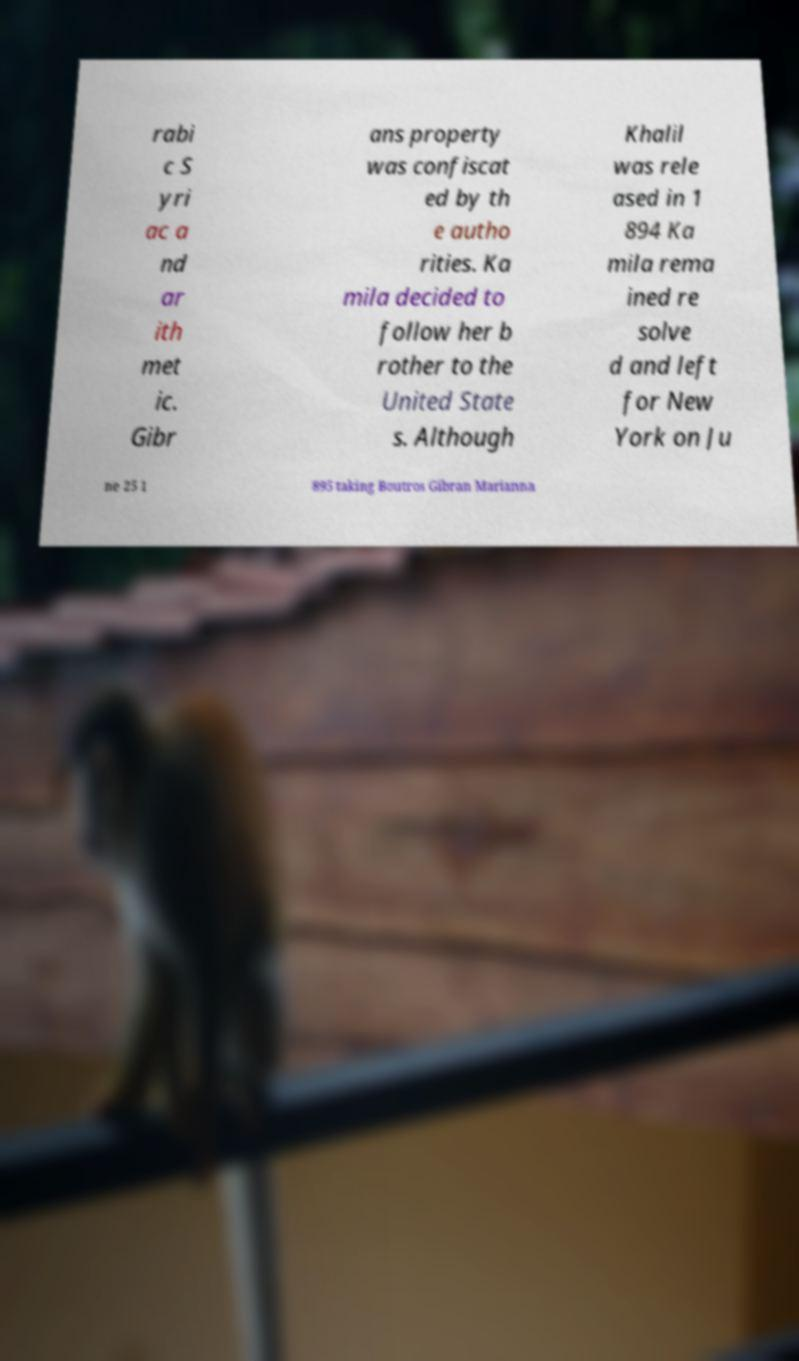Could you assist in decoding the text presented in this image and type it out clearly? rabi c S yri ac a nd ar ith met ic. Gibr ans property was confiscat ed by th e autho rities. Ka mila decided to follow her b rother to the United State s. Although Khalil was rele ased in 1 894 Ka mila rema ined re solve d and left for New York on Ju ne 25 1 895 taking Boutros Gibran Marianna 